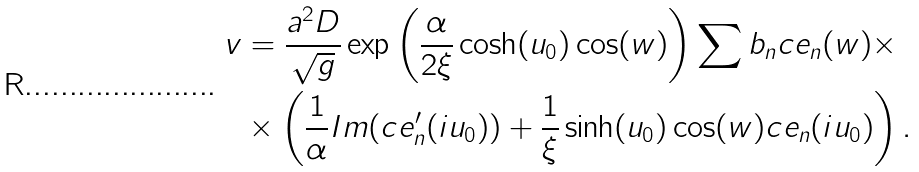<formula> <loc_0><loc_0><loc_500><loc_500>v & = \frac { a ^ { 2 } D } { \sqrt { g } } \exp \left ( \frac { \alpha } { 2 \xi } \cosh ( u _ { 0 } ) \cos ( w ) \right ) \sum b _ { n } c e _ { n } ( w ) \times \\ & \times \left ( \frac { 1 } { \alpha } I m ( c e _ { n } ^ { \prime } ( i u _ { 0 } ) ) + \frac { 1 } { \xi } \sinh ( u _ { 0 } ) \cos ( w ) c e _ { n } ( i u _ { 0 } ) \right ) .</formula> 